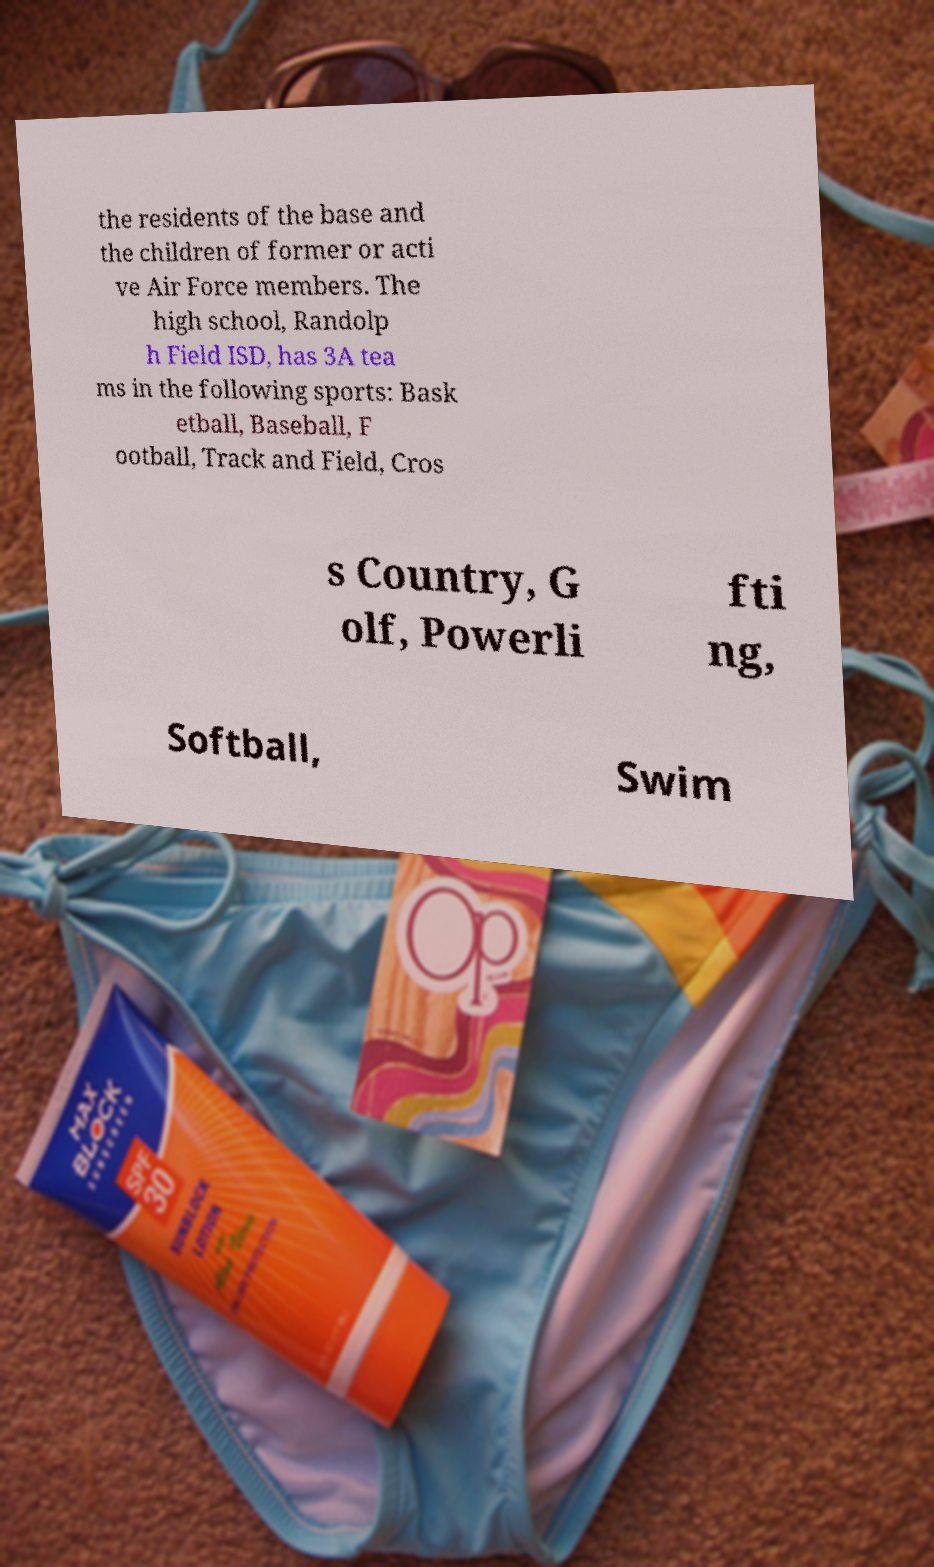For documentation purposes, I need the text within this image transcribed. Could you provide that? the residents of the base and the children of former or acti ve Air Force members. The high school, Randolp h Field ISD, has 3A tea ms in the following sports: Bask etball, Baseball, F ootball, Track and Field, Cros s Country, G olf, Powerli fti ng, Softball, Swim 